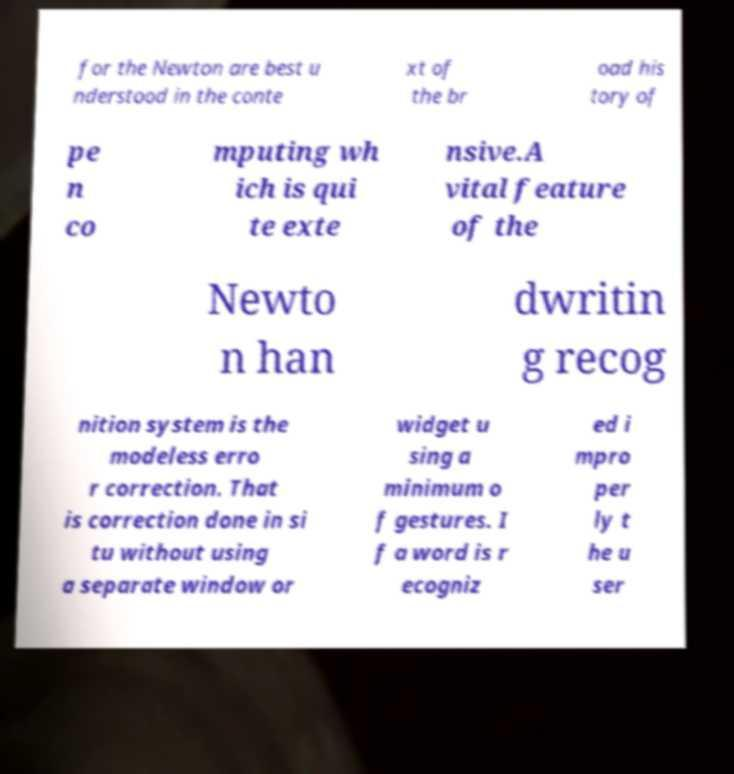Please identify and transcribe the text found in this image. for the Newton are best u nderstood in the conte xt of the br oad his tory of pe n co mputing wh ich is qui te exte nsive.A vital feature of the Newto n han dwritin g recog nition system is the modeless erro r correction. That is correction done in si tu without using a separate window or widget u sing a minimum o f gestures. I f a word is r ecogniz ed i mpro per ly t he u ser 